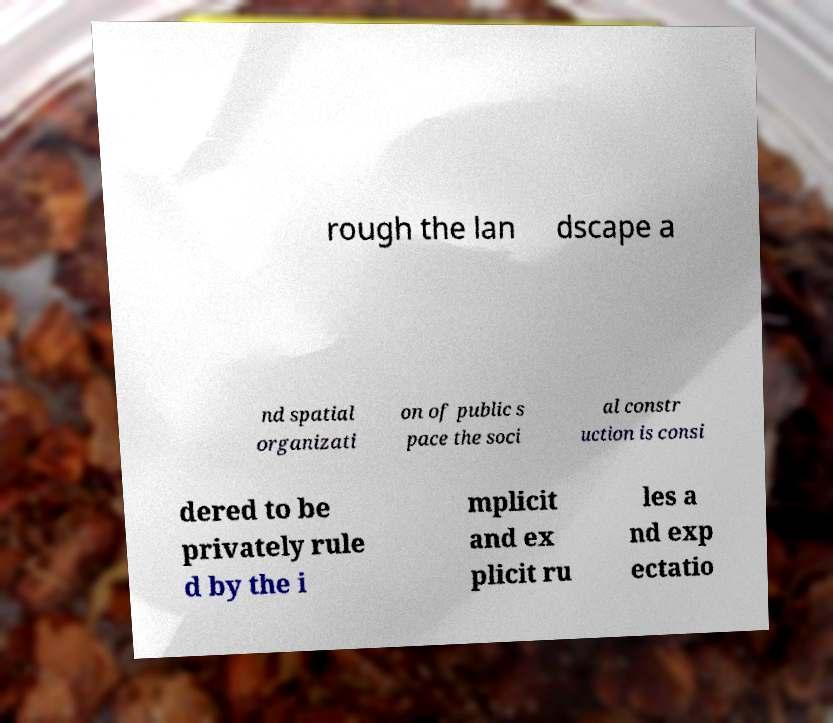Please identify and transcribe the text found in this image. rough the lan dscape a nd spatial organizati on of public s pace the soci al constr uction is consi dered to be privately rule d by the i mplicit and ex plicit ru les a nd exp ectatio 